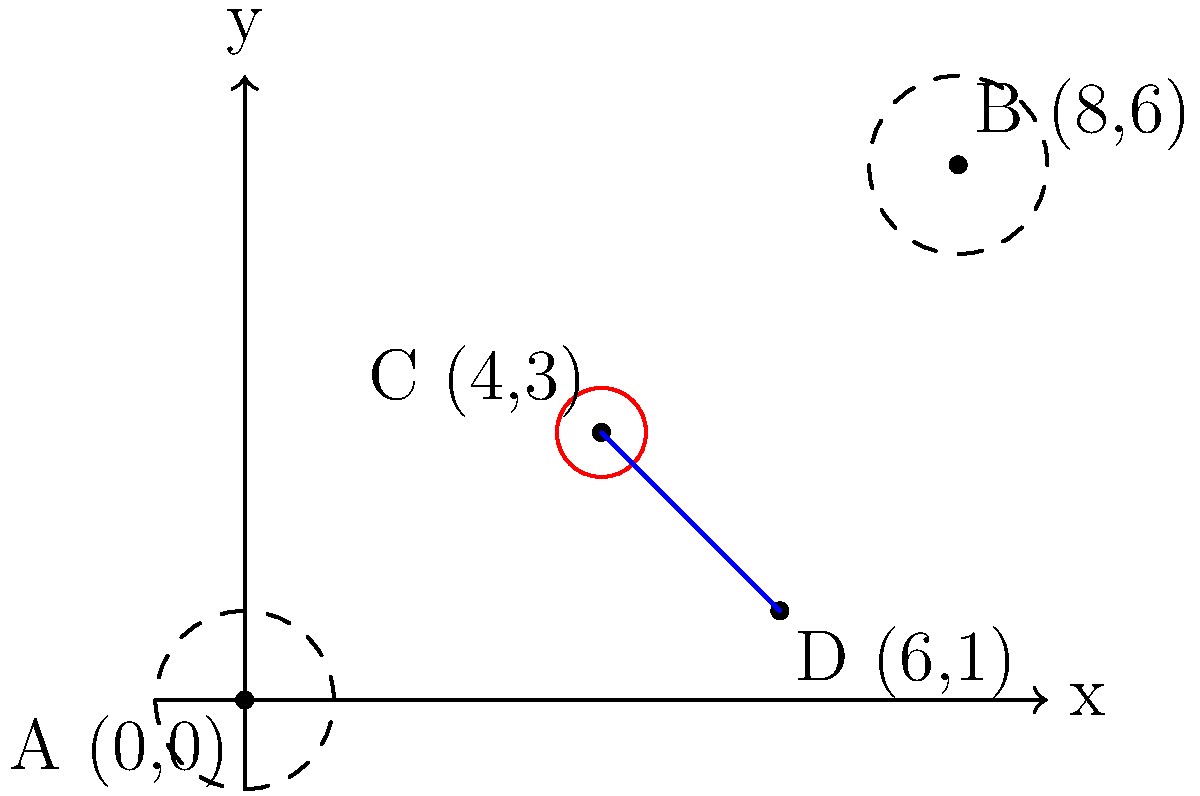A local airport is considering a new development project. On a coordinate plane, two endangered species habitats are centered at A(0,0) and B(8,6), each with a radius of 1 unit. The proposed development site is at C(4,3). If a straight path from the development site to point D(6,1) is planned, what is the shortest distance between this path and either of the habitat areas? Round your answer to two decimal places. To solve this problem, we'll follow these steps:

1) First, we need to find the equation of the line CD:
   Using the point-slope form: $y - y_1 = m(x - x_1)$
   Slope $m = \frac{y_2 - y_1}{x_2 - x_1} = \frac{1-3}{6-4} = -1$
   
   Equation: $y - 3 = -1(x - 4)$
   Simplified: $y = -x + 7$

2) Now, we need to find the distance from this line to both points A and B.

3) The formula for the distance $d$ from a point $(x_0, y_0)$ to a line $ax + by + c = 0$ is:
   $d = \frac{|ax_0 + by_0 + c|}{\sqrt{a^2 + b^2}}$

4) Our line equation $y = -x + 7$ can be rewritten as $x + y - 7 = 0$
   So, $a=1$, $b=1$, and $c=-7$

5) For point A(0,0):
   $d_A = \frac{|1(0) + 1(0) - 7|}{\sqrt{1^2 + 1^2}} = \frac{7}{\sqrt{2}} \approx 4.95$

6) For point B(8,6):
   $d_B = \frac{|1(8) + 1(6) - 7|}{\sqrt{1^2 + 1^2}} = \frac{7}{\sqrt{2}} \approx 4.95$

7) The shortest distance to either habitat is $4.95 - 1 = 3.95$ (subtracting the radius of the habitat area).
Answer: 3.95 units 